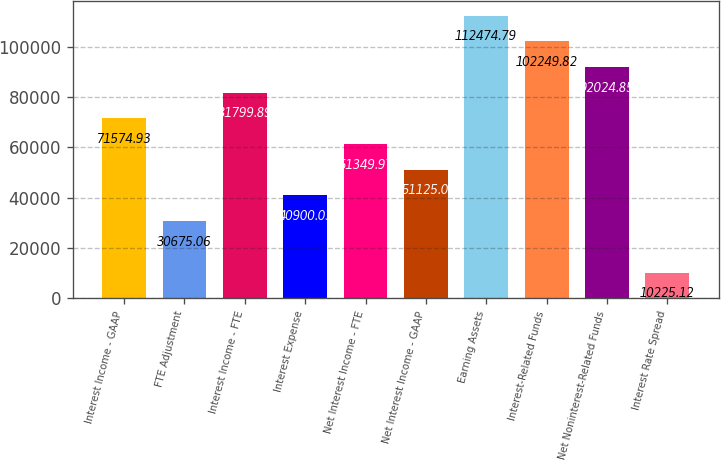Convert chart to OTSL. <chart><loc_0><loc_0><loc_500><loc_500><bar_chart><fcel>Interest Income - GAAP<fcel>FTE Adjustment<fcel>Interest Income - FTE<fcel>Interest Expense<fcel>Net Interest Income - FTE<fcel>Net Interest Income - GAAP<fcel>Earning Assets<fcel>Interest-Related Funds<fcel>Net Noninterest-Related Funds<fcel>Interest Rate Spread<nl><fcel>71574.9<fcel>30675.1<fcel>81799.9<fcel>40900<fcel>61350<fcel>51125<fcel>112475<fcel>102250<fcel>92024.9<fcel>10225.1<nl></chart> 